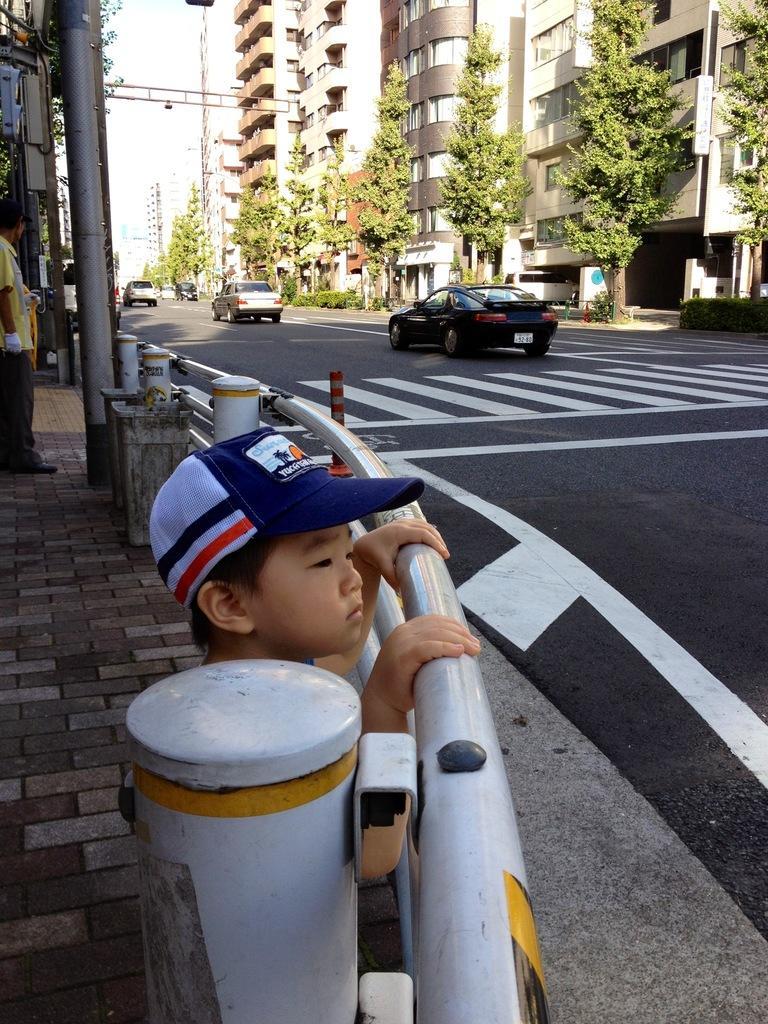Could you give a brief overview of what you see in this image? In this image we can see some vehicles on the road. In the background of the image there are some trees, buildings and other objects. On the left side of the image there are persons, walkway, iron objects and other objects. On the right side bottom of the image there is the road. 